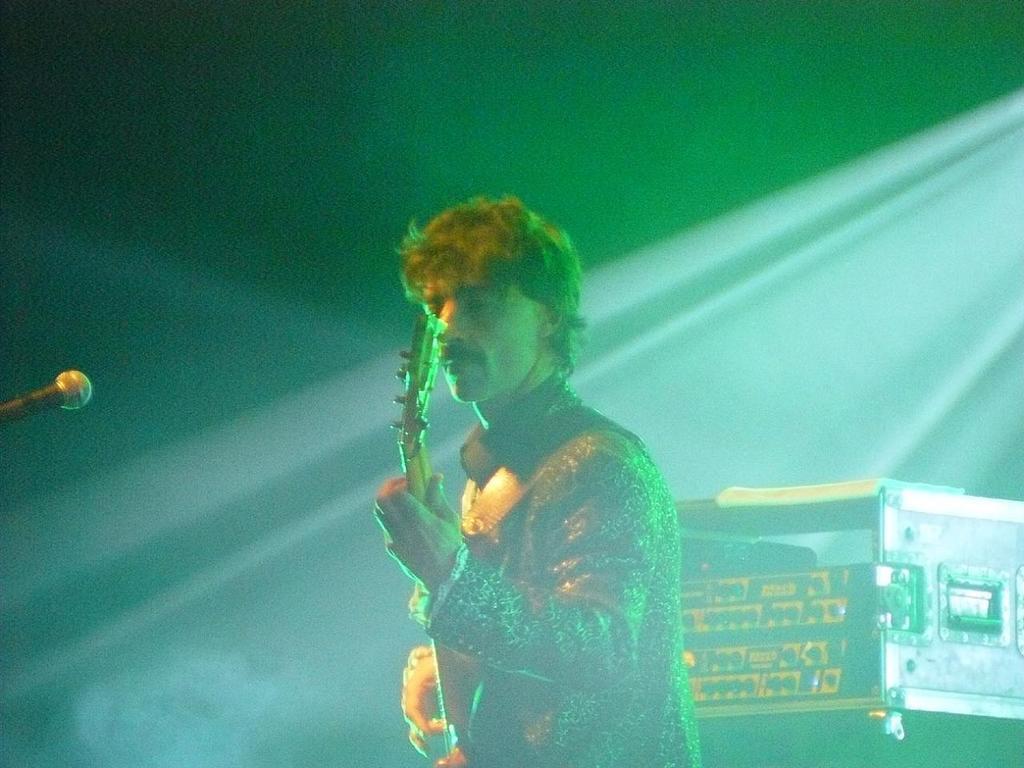Could you give a brief overview of what you see in this image? In the image there is a man standing and holding a guitar in the hand. On the left side of the image there is a mic. Behind the man there is a box. 